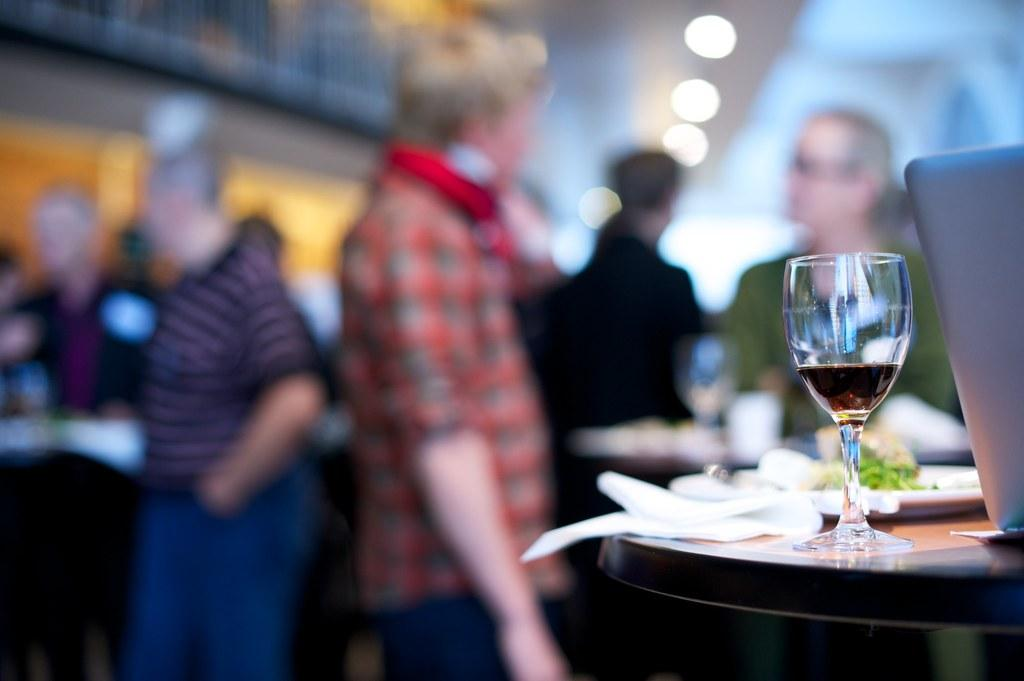How many people are in the image? There is a group of people in the image. What are the people in the image doing? The people are standing. What type of glass can be seen in the image? There is a wine glass in the image. What is on the table in the image? There is a plate with food on the table in the image. What is the name of the person with the most prominent nerve in the image? There is no information about the names of the people in the image, nor is there any mention of nerves. 